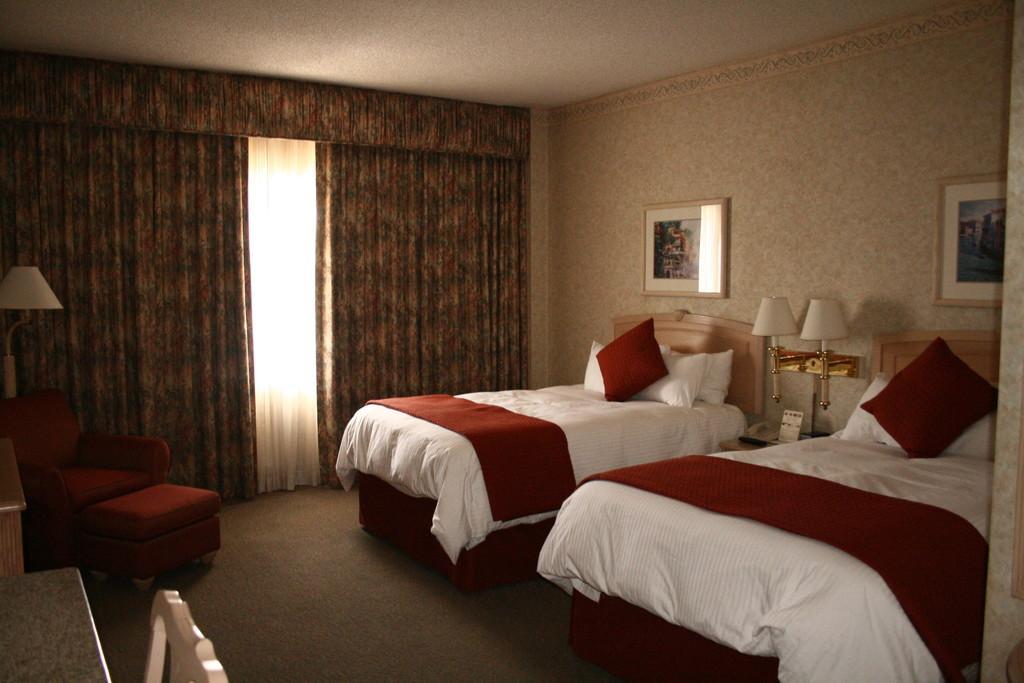Please provide a concise description of this image. In this picture we can see a room with two beds and on beds we can see bed sheets, pillows and in between the beds we have two lamps and here in background we can see curtains with window, wall with frames, chair, lamp. 